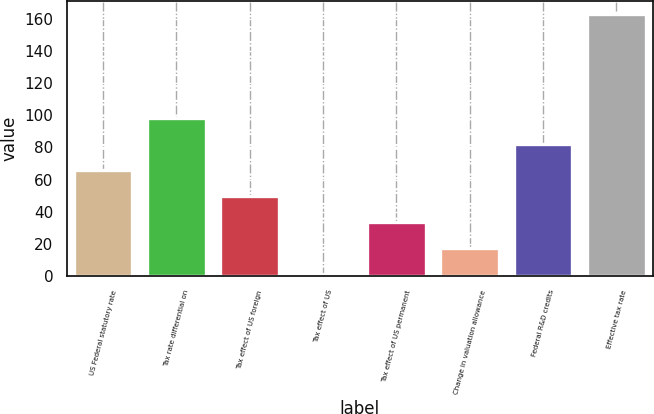<chart> <loc_0><loc_0><loc_500><loc_500><bar_chart><fcel>US Federal statutory rate<fcel>Tax rate differential on<fcel>Tax effect of US foreign<fcel>Tax effect of US<fcel>Tax effect of US permanent<fcel>Change in valuation allowance<fcel>Federal R&D credits<fcel>Effective tax rate<nl><fcel>65.8<fcel>98.2<fcel>49.6<fcel>1<fcel>33.4<fcel>17.2<fcel>82<fcel>163<nl></chart> 